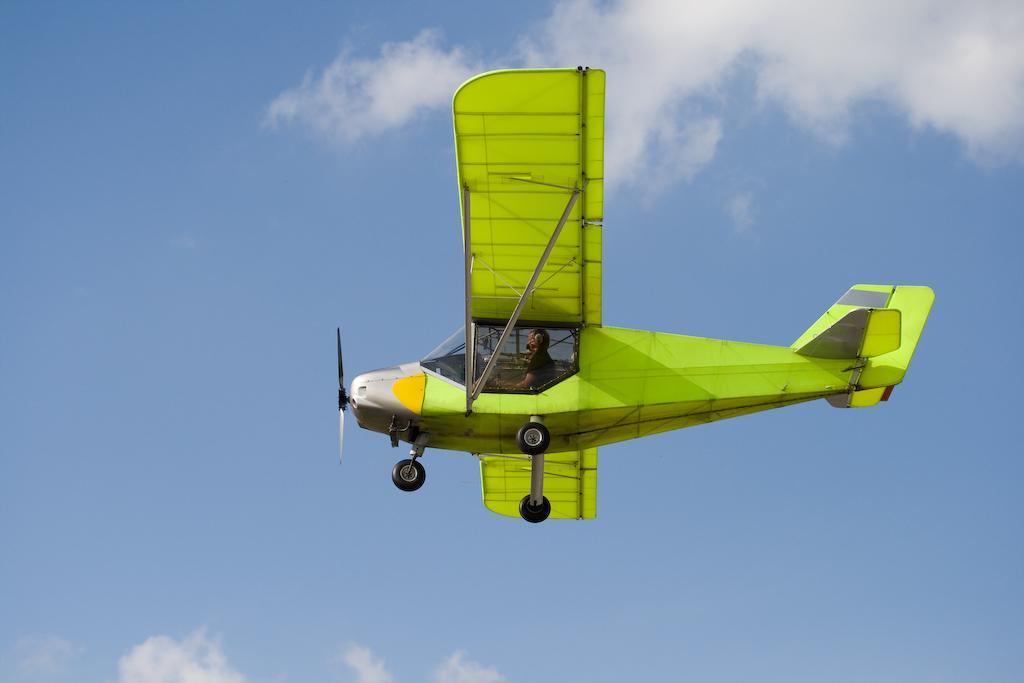Please provide a concise description of this image. In this picture I can see an aircraft in air and I see a person sitting in it. In the background I can see the clear sky. 